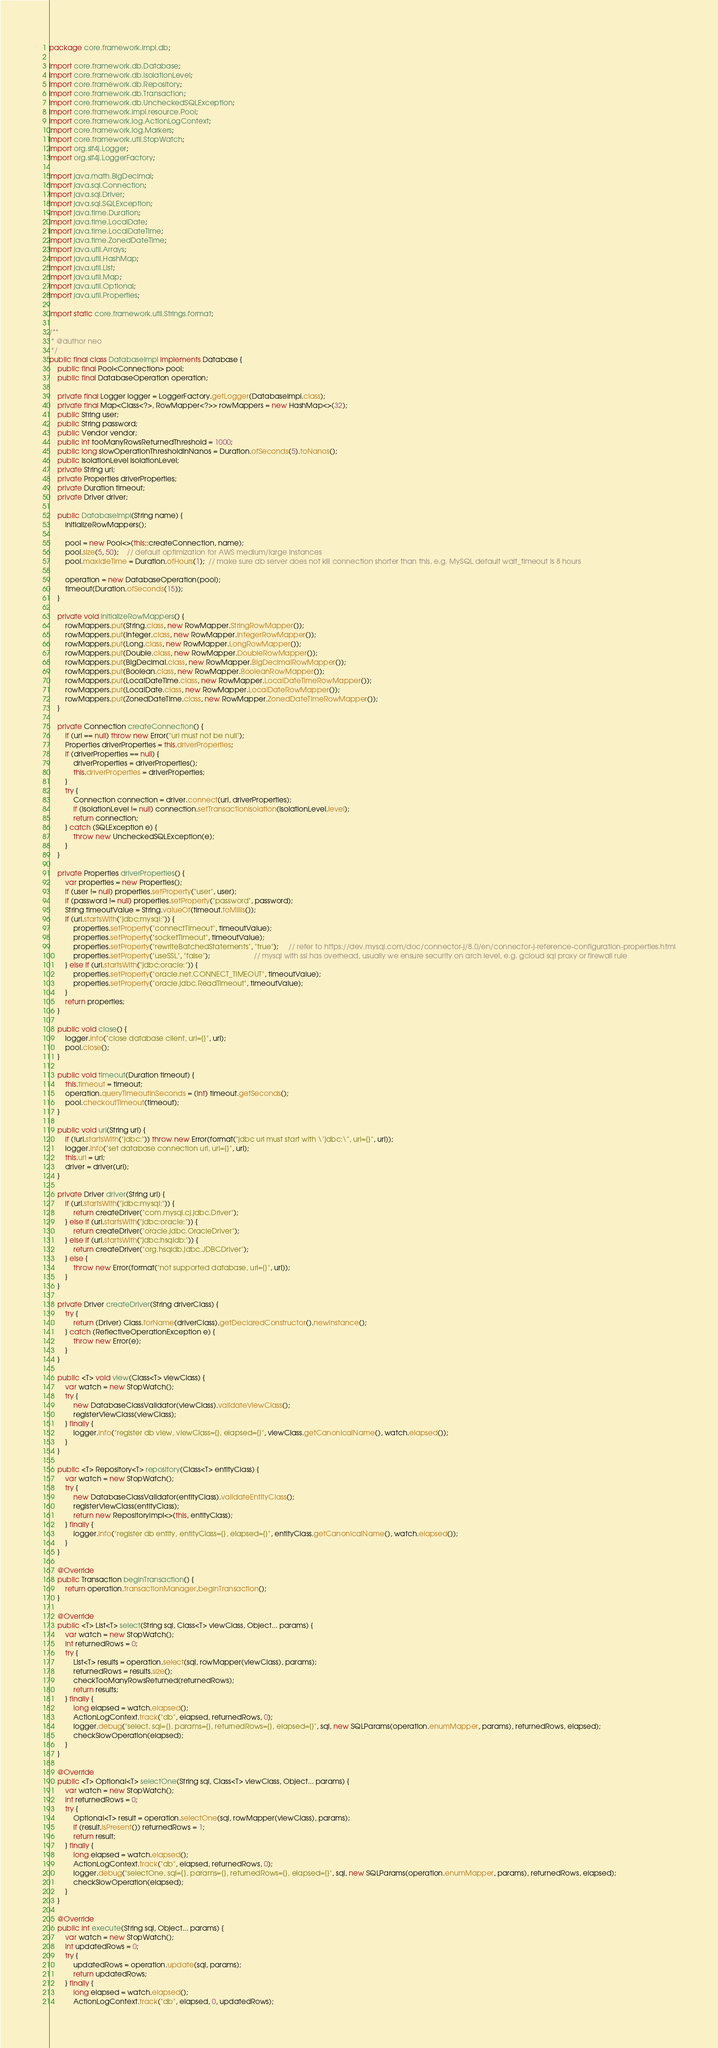Convert code to text. <code><loc_0><loc_0><loc_500><loc_500><_Java_>package core.framework.impl.db;

import core.framework.db.Database;
import core.framework.db.IsolationLevel;
import core.framework.db.Repository;
import core.framework.db.Transaction;
import core.framework.db.UncheckedSQLException;
import core.framework.impl.resource.Pool;
import core.framework.log.ActionLogContext;
import core.framework.log.Markers;
import core.framework.util.StopWatch;
import org.slf4j.Logger;
import org.slf4j.LoggerFactory;

import java.math.BigDecimal;
import java.sql.Connection;
import java.sql.Driver;
import java.sql.SQLException;
import java.time.Duration;
import java.time.LocalDate;
import java.time.LocalDateTime;
import java.time.ZonedDateTime;
import java.util.Arrays;
import java.util.HashMap;
import java.util.List;
import java.util.Map;
import java.util.Optional;
import java.util.Properties;

import static core.framework.util.Strings.format;

/**
 * @author neo
 */
public final class DatabaseImpl implements Database {
    public final Pool<Connection> pool;
    public final DatabaseOperation operation;

    private final Logger logger = LoggerFactory.getLogger(DatabaseImpl.class);
    private final Map<Class<?>, RowMapper<?>> rowMappers = new HashMap<>(32);
    public String user;
    public String password;
    public Vendor vendor;
    public int tooManyRowsReturnedThreshold = 1000;
    public long slowOperationThresholdInNanos = Duration.ofSeconds(5).toNanos();
    public IsolationLevel isolationLevel;
    private String url;
    private Properties driverProperties;
    private Duration timeout;
    private Driver driver;

    public DatabaseImpl(String name) {
        initializeRowMappers();

        pool = new Pool<>(this::createConnection, name);
        pool.size(5, 50);    // default optimization for AWS medium/large instances
        pool.maxIdleTime = Duration.ofHours(1);  // make sure db server does not kill connection shorter than this, e.g. MySQL default wait_timeout is 8 hours

        operation = new DatabaseOperation(pool);
        timeout(Duration.ofSeconds(15));
    }

    private void initializeRowMappers() {
        rowMappers.put(String.class, new RowMapper.StringRowMapper());
        rowMappers.put(Integer.class, new RowMapper.IntegerRowMapper());
        rowMappers.put(Long.class, new RowMapper.LongRowMapper());
        rowMappers.put(Double.class, new RowMapper.DoubleRowMapper());
        rowMappers.put(BigDecimal.class, new RowMapper.BigDecimalRowMapper());
        rowMappers.put(Boolean.class, new RowMapper.BooleanRowMapper());
        rowMappers.put(LocalDateTime.class, new RowMapper.LocalDateTimeRowMapper());
        rowMappers.put(LocalDate.class, new RowMapper.LocalDateRowMapper());
        rowMappers.put(ZonedDateTime.class, new RowMapper.ZonedDateTimeRowMapper());
    }

    private Connection createConnection() {
        if (url == null) throw new Error("url must not be null");
        Properties driverProperties = this.driverProperties;
        if (driverProperties == null) {
            driverProperties = driverProperties();
            this.driverProperties = driverProperties;
        }
        try {
            Connection connection = driver.connect(url, driverProperties);
            if (isolationLevel != null) connection.setTransactionIsolation(isolationLevel.level);
            return connection;
        } catch (SQLException e) {
            throw new UncheckedSQLException(e);
        }
    }

    private Properties driverProperties() {
        var properties = new Properties();
        if (user != null) properties.setProperty("user", user);
        if (password != null) properties.setProperty("password", password);
        String timeoutValue = String.valueOf(timeout.toMillis());
        if (url.startsWith("jdbc:mysql:")) {
            properties.setProperty("connectTimeout", timeoutValue);
            properties.setProperty("socketTimeout", timeoutValue);
            properties.setProperty("rewriteBatchedStatements", "true");     // refer to https://dev.mysql.com/doc/connector-j/8.0/en/connector-j-reference-configuration-properties.html
            properties.setProperty("useSSL", "false");                      // mysql with ssl has overhead, usually we ensure security on arch level, e.g. gcloud sql proxy or firewall rule
        } else if (url.startsWith("jdbc:oracle:")) {
            properties.setProperty("oracle.net.CONNECT_TIMEOUT", timeoutValue);
            properties.setProperty("oracle.jdbc.ReadTimeout", timeoutValue);
        }
        return properties;
    }

    public void close() {
        logger.info("close database client, url={}", url);
        pool.close();
    }

    public void timeout(Duration timeout) {
        this.timeout = timeout;
        operation.queryTimeoutInSeconds = (int) timeout.getSeconds();
        pool.checkoutTimeout(timeout);
    }

    public void url(String url) {
        if (!url.startsWith("jdbc:")) throw new Error(format("jdbc url must start with \"jdbc:\", url={}", url));
        logger.info("set database connection url, url={}", url);
        this.url = url;
        driver = driver(url);
    }

    private Driver driver(String url) {
        if (url.startsWith("jdbc:mysql:")) {
            return createDriver("com.mysql.cj.jdbc.Driver");
        } else if (url.startsWith("jdbc:oracle:")) {
            return createDriver("oracle.jdbc.OracleDriver");
        } else if (url.startsWith("jdbc:hsqldb:")) {
            return createDriver("org.hsqldb.jdbc.JDBCDriver");
        } else {
            throw new Error(format("not supported database, url={}", url));
        }
    }

    private Driver createDriver(String driverClass) {
        try {
            return (Driver) Class.forName(driverClass).getDeclaredConstructor().newInstance();
        } catch (ReflectiveOperationException e) {
            throw new Error(e);
        }
    }

    public <T> void view(Class<T> viewClass) {
        var watch = new StopWatch();
        try {
            new DatabaseClassValidator(viewClass).validateViewClass();
            registerViewClass(viewClass);
        } finally {
            logger.info("register db view, viewClass={}, elapsed={}", viewClass.getCanonicalName(), watch.elapsed());
        }
    }

    public <T> Repository<T> repository(Class<T> entityClass) {
        var watch = new StopWatch();
        try {
            new DatabaseClassValidator(entityClass).validateEntityClass();
            registerViewClass(entityClass);
            return new RepositoryImpl<>(this, entityClass);
        } finally {
            logger.info("register db entity, entityClass={}, elapsed={}", entityClass.getCanonicalName(), watch.elapsed());
        }
    }

    @Override
    public Transaction beginTransaction() {
        return operation.transactionManager.beginTransaction();
    }

    @Override
    public <T> List<T> select(String sql, Class<T> viewClass, Object... params) {
        var watch = new StopWatch();
        int returnedRows = 0;
        try {
            List<T> results = operation.select(sql, rowMapper(viewClass), params);
            returnedRows = results.size();
            checkTooManyRowsReturned(returnedRows);
            return results;
        } finally {
            long elapsed = watch.elapsed();
            ActionLogContext.track("db", elapsed, returnedRows, 0);
            logger.debug("select, sql={}, params={}, returnedRows={}, elapsed={}", sql, new SQLParams(operation.enumMapper, params), returnedRows, elapsed);
            checkSlowOperation(elapsed);
        }
    }

    @Override
    public <T> Optional<T> selectOne(String sql, Class<T> viewClass, Object... params) {
        var watch = new StopWatch();
        int returnedRows = 0;
        try {
            Optional<T> result = operation.selectOne(sql, rowMapper(viewClass), params);
            if (result.isPresent()) returnedRows = 1;
            return result;
        } finally {
            long elapsed = watch.elapsed();
            ActionLogContext.track("db", elapsed, returnedRows, 0);
            logger.debug("selectOne, sql={}, params={}, returnedRows={}, elapsed={}", sql, new SQLParams(operation.enumMapper, params), returnedRows, elapsed);
            checkSlowOperation(elapsed);
        }
    }

    @Override
    public int execute(String sql, Object... params) {
        var watch = new StopWatch();
        int updatedRows = 0;
        try {
            updatedRows = operation.update(sql, params);
            return updatedRows;
        } finally {
            long elapsed = watch.elapsed();
            ActionLogContext.track("db", elapsed, 0, updatedRows);</code> 